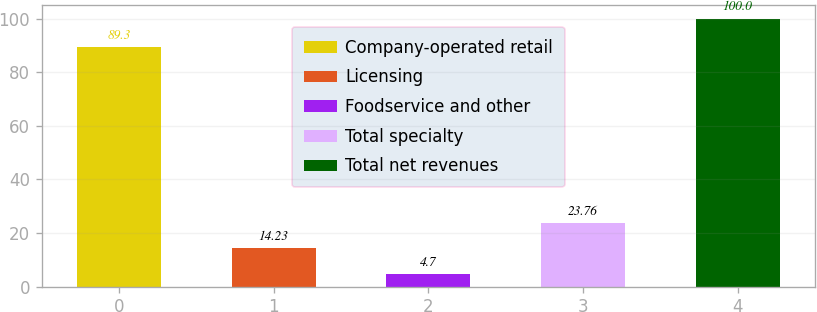Convert chart. <chart><loc_0><loc_0><loc_500><loc_500><bar_chart><fcel>Company-operated retail<fcel>Licensing<fcel>Foodservice and other<fcel>Total specialty<fcel>Total net revenues<nl><fcel>89.3<fcel>14.23<fcel>4.7<fcel>23.76<fcel>100<nl></chart> 